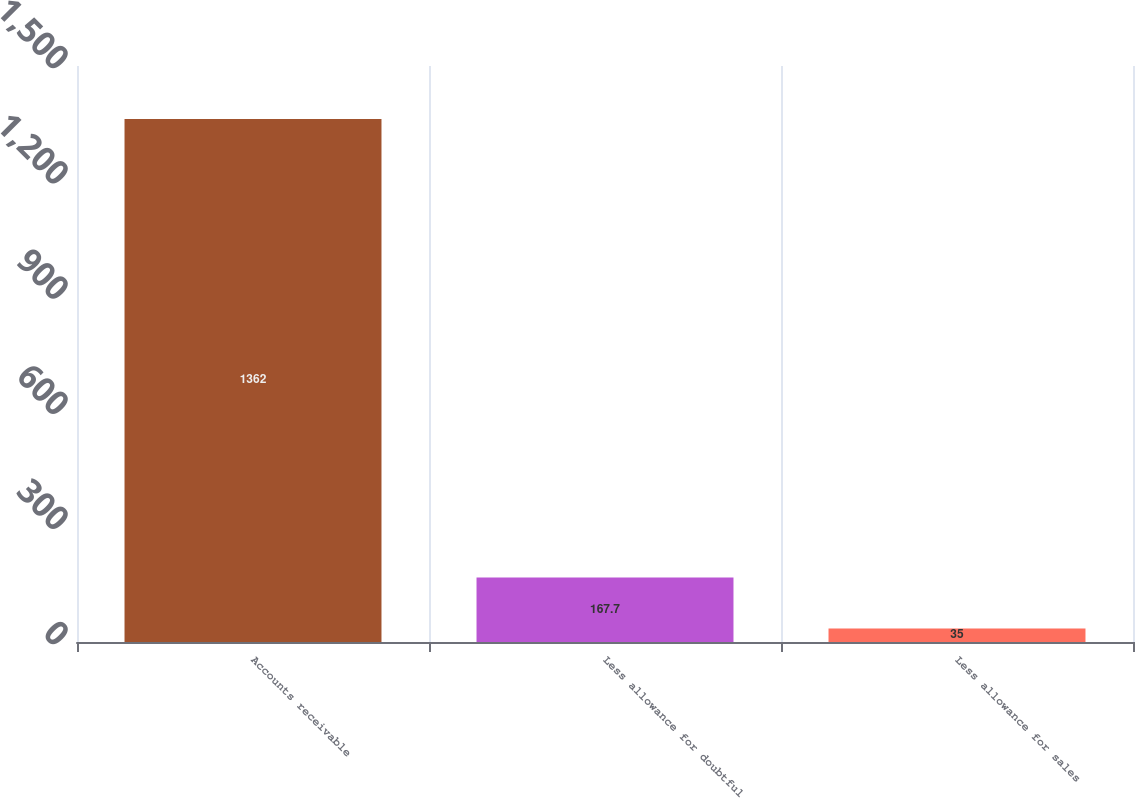Convert chart to OTSL. <chart><loc_0><loc_0><loc_500><loc_500><bar_chart><fcel>Accounts receivable<fcel>Less allowance for doubtful<fcel>Less allowance for sales<nl><fcel>1362<fcel>167.7<fcel>35<nl></chart> 